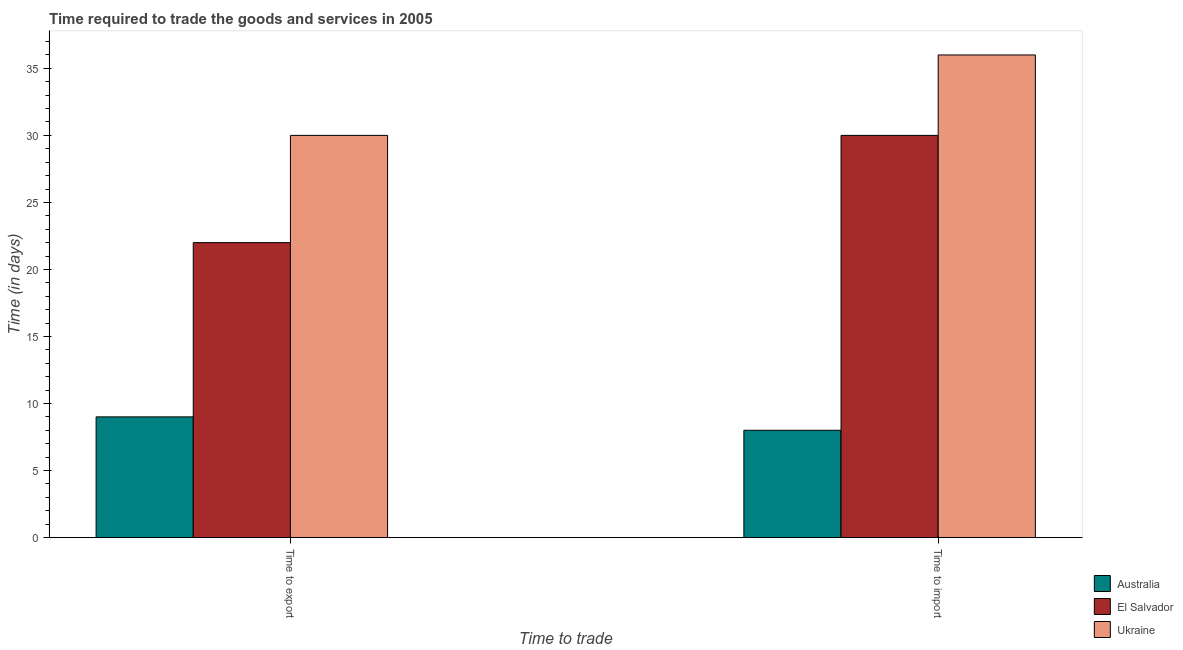Are the number of bars per tick equal to the number of legend labels?
Give a very brief answer. Yes. How many bars are there on the 1st tick from the left?
Your response must be concise. 3. How many bars are there on the 1st tick from the right?
Provide a succinct answer. 3. What is the label of the 1st group of bars from the left?
Your answer should be compact. Time to export. What is the time to import in Australia?
Keep it short and to the point. 8. Across all countries, what is the maximum time to export?
Your answer should be compact. 30. Across all countries, what is the minimum time to export?
Provide a succinct answer. 9. In which country was the time to import maximum?
Your answer should be compact. Ukraine. In which country was the time to export minimum?
Your answer should be compact. Australia. What is the total time to export in the graph?
Offer a terse response. 61. What is the difference between the time to export in Ukraine and that in El Salvador?
Ensure brevity in your answer.  8. What is the difference between the time to export in El Salvador and the time to import in Ukraine?
Provide a succinct answer. -14. What is the average time to import per country?
Provide a short and direct response. 24.67. What is the difference between the time to export and time to import in Australia?
Your answer should be very brief. 1. In how many countries, is the time to import greater than 28 days?
Your response must be concise. 2. What is the ratio of the time to export in Australia to that in El Salvador?
Give a very brief answer. 0.41. Is the time to import in El Salvador less than that in Australia?
Keep it short and to the point. No. What does the 2nd bar from the left in Time to import represents?
Your answer should be very brief. El Salvador. What does the 3rd bar from the right in Time to import represents?
Give a very brief answer. Australia. How many countries are there in the graph?
Make the answer very short. 3. Are the values on the major ticks of Y-axis written in scientific E-notation?
Offer a very short reply. No. Does the graph contain grids?
Your answer should be very brief. No. Where does the legend appear in the graph?
Your answer should be compact. Bottom right. What is the title of the graph?
Make the answer very short. Time required to trade the goods and services in 2005. What is the label or title of the X-axis?
Your answer should be very brief. Time to trade. What is the label or title of the Y-axis?
Your response must be concise. Time (in days). What is the Time (in days) of El Salvador in Time to export?
Give a very brief answer. 22. What is the Time (in days) in El Salvador in Time to import?
Make the answer very short. 30. What is the Time (in days) in Ukraine in Time to import?
Offer a terse response. 36. Across all Time to trade, what is the maximum Time (in days) in Ukraine?
Offer a very short reply. 36. Across all Time to trade, what is the minimum Time (in days) of Australia?
Provide a succinct answer. 8. Across all Time to trade, what is the minimum Time (in days) of Ukraine?
Your answer should be very brief. 30. What is the total Time (in days) in Ukraine in the graph?
Provide a succinct answer. 66. What is the difference between the Time (in days) in El Salvador in Time to export and that in Time to import?
Your answer should be very brief. -8. What is the difference between the Time (in days) of Ukraine in Time to export and that in Time to import?
Offer a terse response. -6. What is the difference between the Time (in days) of Australia in Time to export and the Time (in days) of Ukraine in Time to import?
Offer a very short reply. -27. What is the difference between the Time (in days) in El Salvador in Time to export and the Time (in days) in Ukraine in Time to import?
Make the answer very short. -14. What is the difference between the Time (in days) in Australia and Time (in days) in El Salvador in Time to export?
Your answer should be compact. -13. What is the difference between the Time (in days) of Australia and Time (in days) of Ukraine in Time to export?
Provide a short and direct response. -21. What is the difference between the Time (in days) of El Salvador and Time (in days) of Ukraine in Time to export?
Provide a short and direct response. -8. What is the difference between the Time (in days) in Australia and Time (in days) in Ukraine in Time to import?
Offer a terse response. -28. What is the difference between the Time (in days) in El Salvador and Time (in days) in Ukraine in Time to import?
Offer a very short reply. -6. What is the ratio of the Time (in days) of El Salvador in Time to export to that in Time to import?
Provide a short and direct response. 0.73. What is the difference between the highest and the second highest Time (in days) in Ukraine?
Offer a terse response. 6. What is the difference between the highest and the lowest Time (in days) in Ukraine?
Make the answer very short. 6. 